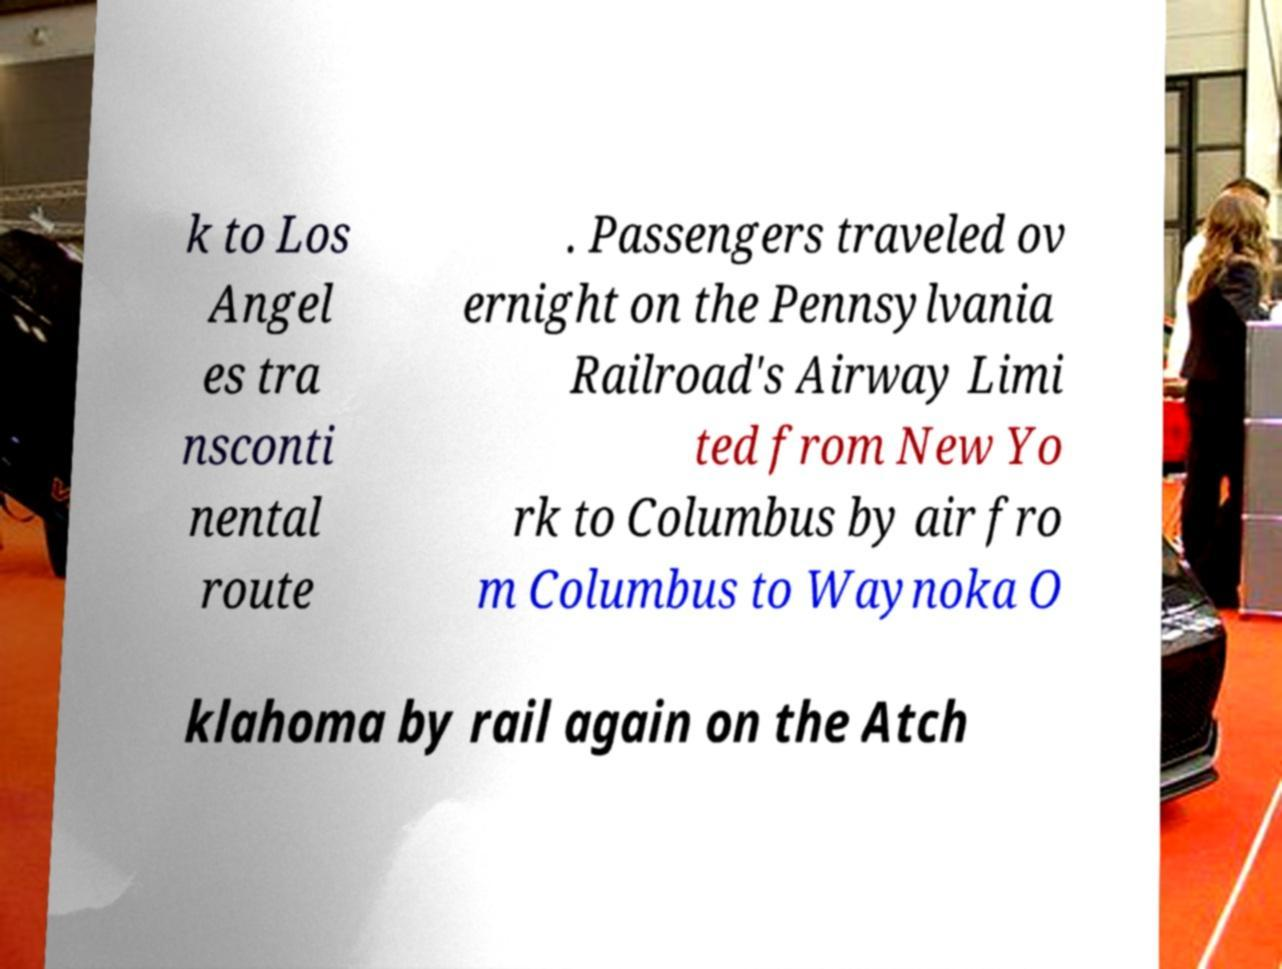Could you extract and type out the text from this image? k to Los Angel es tra nsconti nental route . Passengers traveled ov ernight on the Pennsylvania Railroad's Airway Limi ted from New Yo rk to Columbus by air fro m Columbus to Waynoka O klahoma by rail again on the Atch 